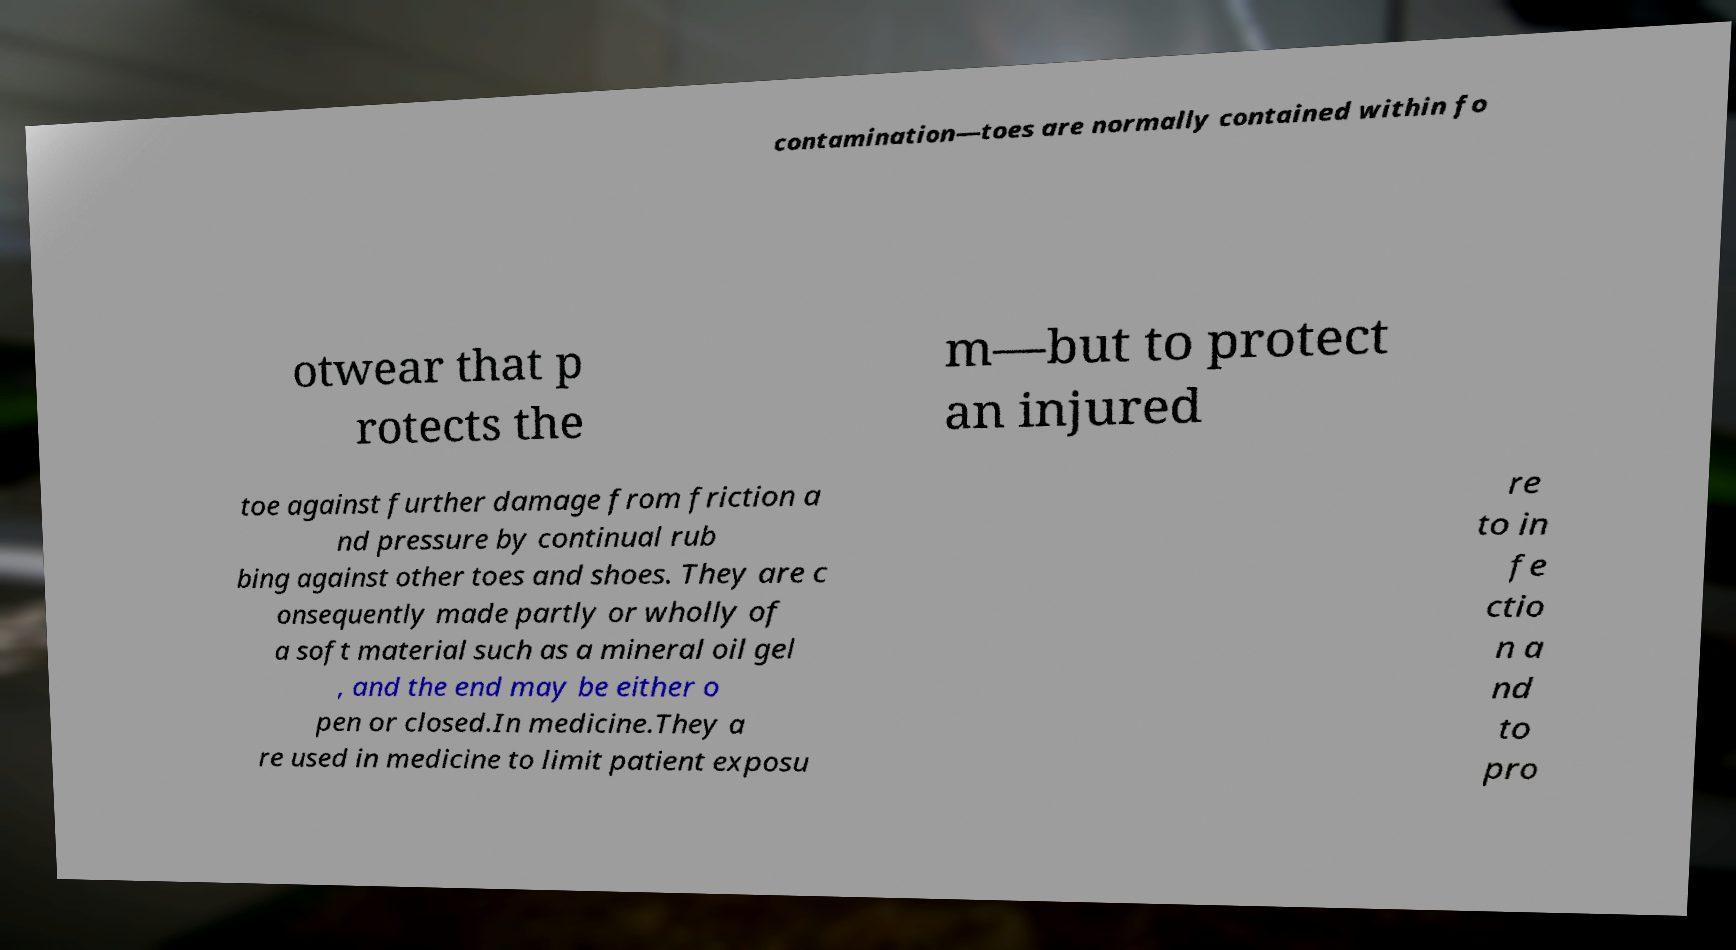Please read and relay the text visible in this image. What does it say? contamination—toes are normally contained within fo otwear that p rotects the m—but to protect an injured toe against further damage from friction a nd pressure by continual rub bing against other toes and shoes. They are c onsequently made partly or wholly of a soft material such as a mineral oil gel , and the end may be either o pen or closed.In medicine.They a re used in medicine to limit patient exposu re to in fe ctio n a nd to pro 